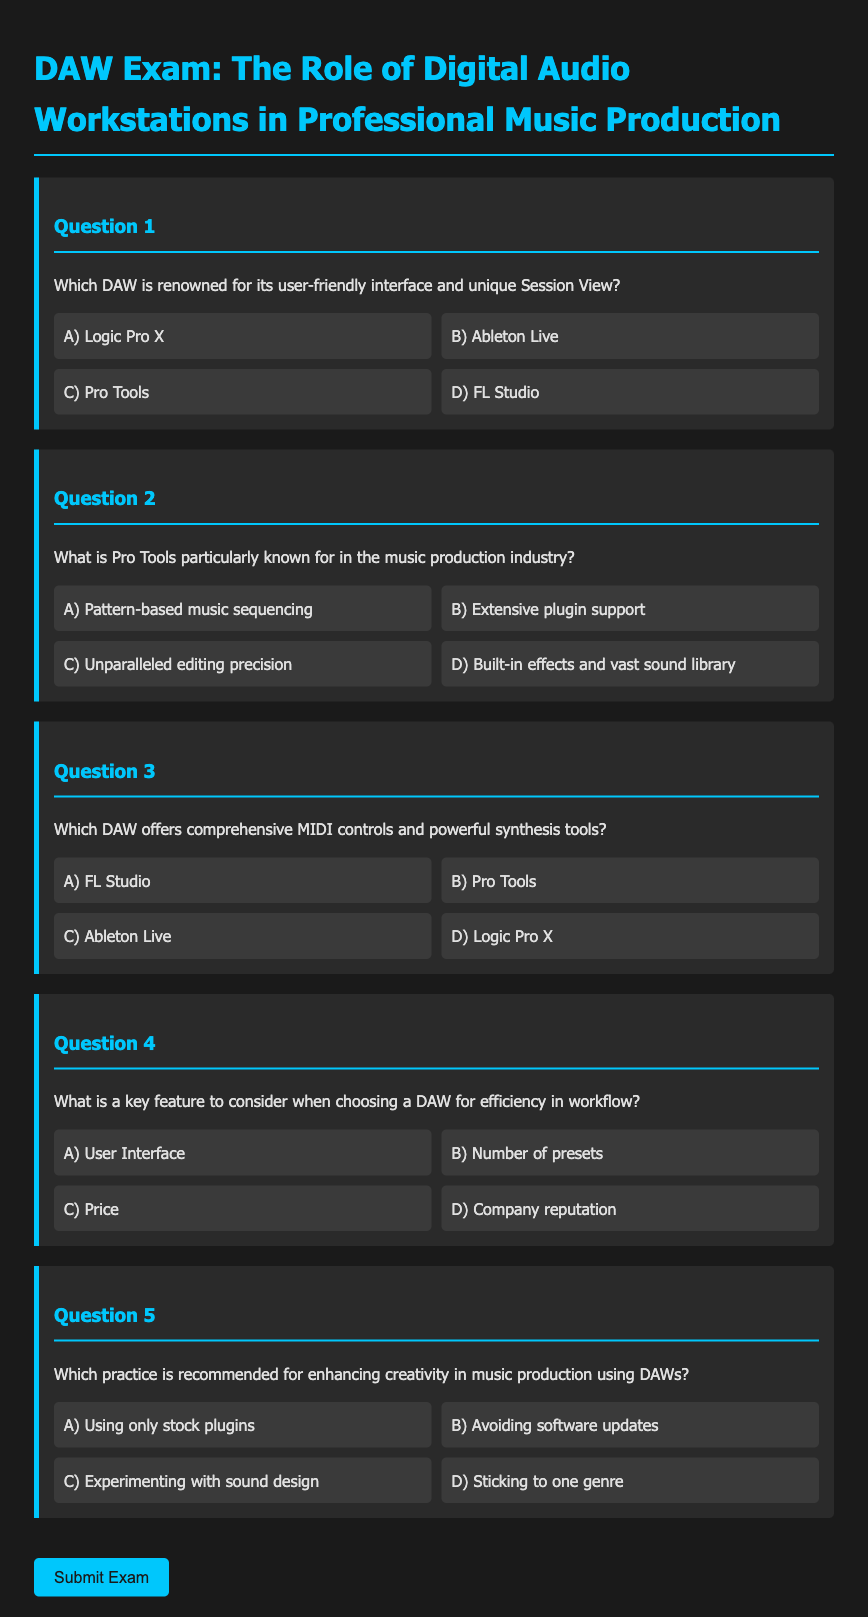What is the title of the exam? The title of the exam is found in the document's heading section, which is "DAW Exam: The Role of Digital Audio Workstations in Professional Music Production."
Answer: DAW Exam: The Role of Digital Audio Workstations in Professional Music Production Which DAW is noted for its Session View? The DAW specifically mentioned for its unique Session View is listed in Question 1 of the document.
Answer: Ableton Live What is Pro Tools particularly well-known for? Pro Tools' reputation in the music production industry is explained in Question 2, which highlights its editing capabilities.
Answer: Unparalleled editing precision Which DAW is highlighted for comprehensive MIDI controls? In Question 3, a specific DAW with notable MIDI controls and synthesis tools is mentioned, allowing easy identification of its features.
Answer: Logic Pro X Which practice enhances creativity in music production? The importance of a particular practice for creativity in music production is outlined in Question 5 of the document.
Answer: Experimenting with sound design 